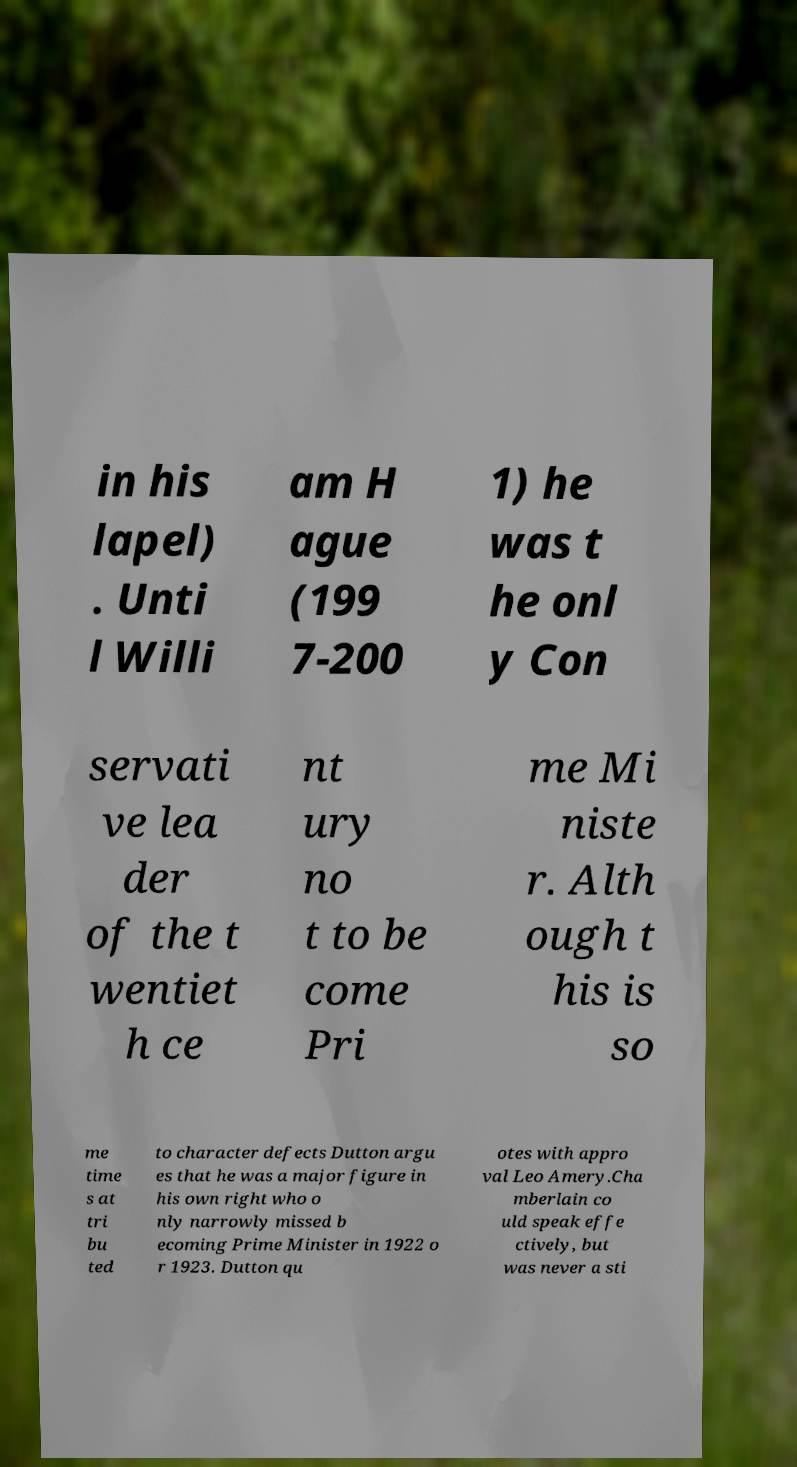Please identify and transcribe the text found in this image. in his lapel) . Unti l Willi am H ague (199 7-200 1) he was t he onl y Con servati ve lea der of the t wentiet h ce nt ury no t to be come Pri me Mi niste r. Alth ough t his is so me time s at tri bu ted to character defects Dutton argu es that he was a major figure in his own right who o nly narrowly missed b ecoming Prime Minister in 1922 o r 1923. Dutton qu otes with appro val Leo Amery.Cha mberlain co uld speak effe ctively, but was never a sti 